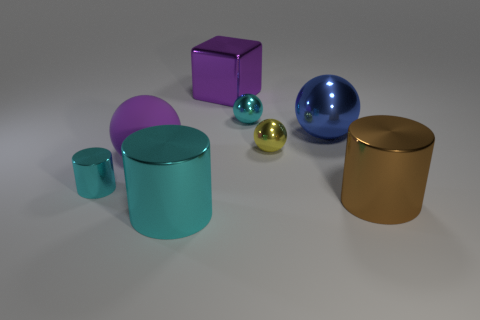What could these objects represent if they were part of a larger symbolic message? If these objects were part of a symbolic message, their uniform yet distinctive shapes could represent individuality within unity. Their metallic nature might suggest strength and resilience, while the careful arrangement might imply balance and order in diversity. 